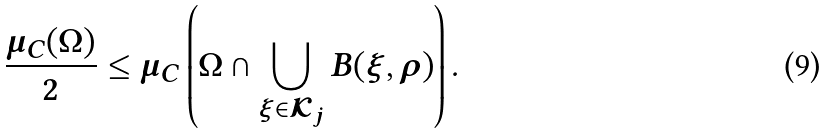<formula> <loc_0><loc_0><loc_500><loc_500>\frac { \mu _ { C } ( \Omega ) } { 2 } \leq \mu _ { C } \left ( \Omega \cap \bigcup _ { \xi \in \mathcal { K } _ { j } } B ( \xi , \rho ) \right ) \text {.}</formula> 